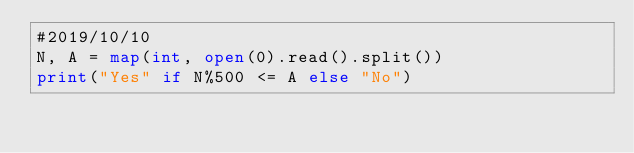Convert code to text. <code><loc_0><loc_0><loc_500><loc_500><_Python_>#2019/10/10
N, A = map(int, open(0).read().split())
print("Yes" if N%500 <= A else "No")</code> 